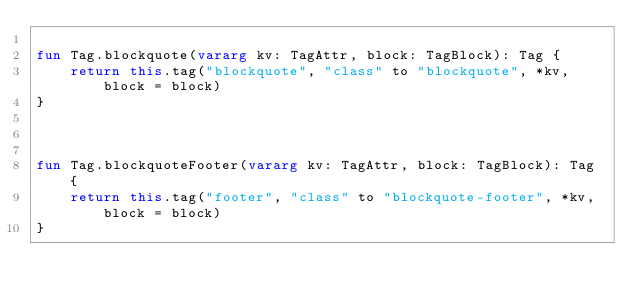Convert code to text. <code><loc_0><loc_0><loc_500><loc_500><_Kotlin_>
fun Tag.blockquote(vararg kv: TagAttr, block: TagBlock): Tag {
	return this.tag("blockquote", "class" to "blockquote", *kv, block = block)
}



fun Tag.blockquoteFooter(vararg kv: TagAttr, block: TagBlock): Tag {
	return this.tag("footer", "class" to "blockquote-footer", *kv, block = block)
}</code> 